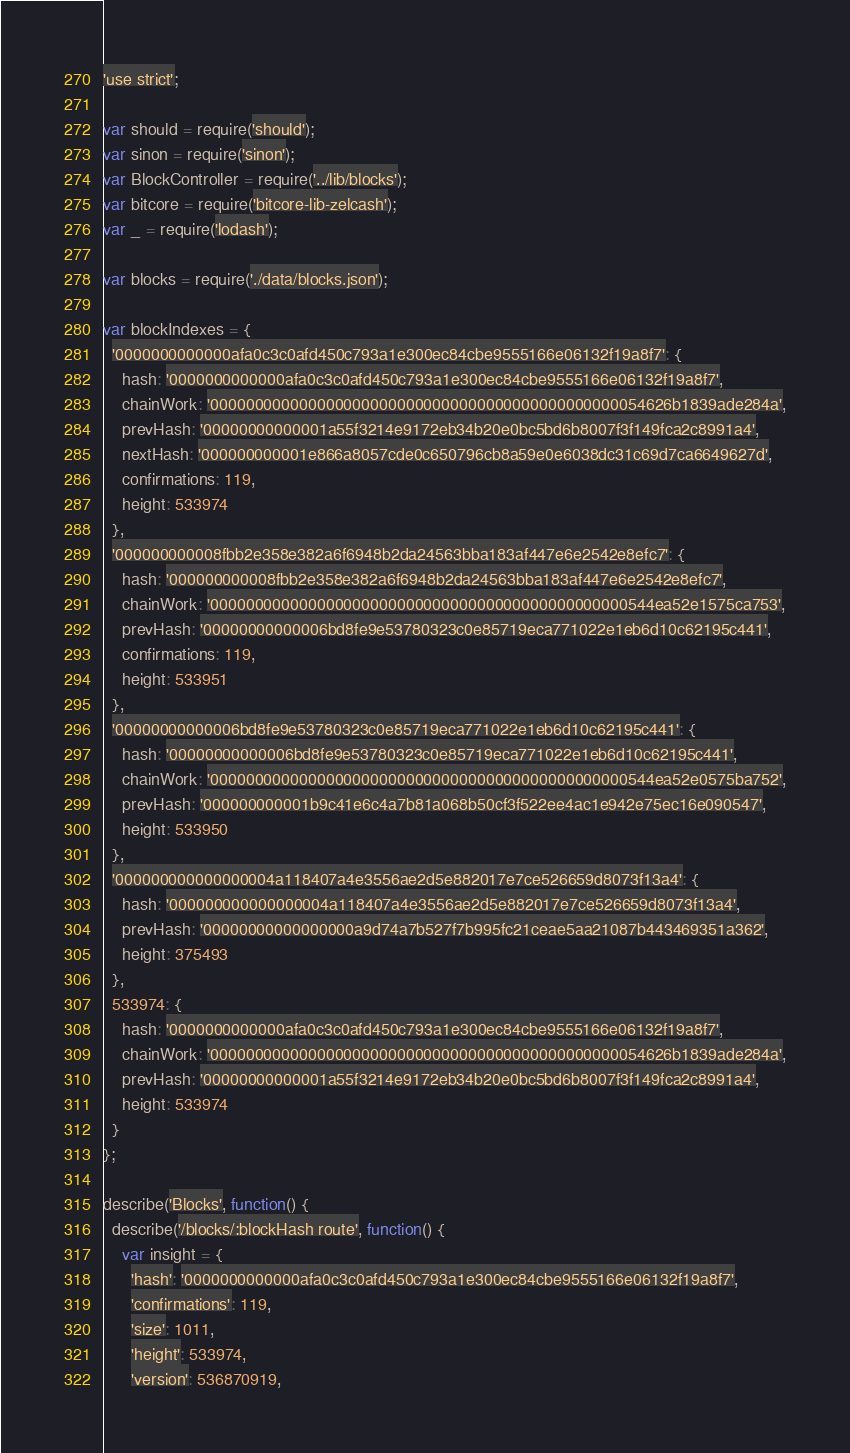<code> <loc_0><loc_0><loc_500><loc_500><_JavaScript_>'use strict';

var should = require('should');
var sinon = require('sinon');
var BlockController = require('../lib/blocks');
var bitcore = require('bitcore-lib-zelcash');
var _ = require('lodash');

var blocks = require('./data/blocks.json');

var blockIndexes = {
  '0000000000000afa0c3c0afd450c793a1e300ec84cbe9555166e06132f19a8f7': {
    hash: '0000000000000afa0c3c0afd450c793a1e300ec84cbe9555166e06132f19a8f7',
    chainWork: '0000000000000000000000000000000000000000000000054626b1839ade284a',
    prevHash: '00000000000001a55f3214e9172eb34b20e0bc5bd6b8007f3f149fca2c8991a4',
    nextHash: '000000000001e866a8057cde0c650796cb8a59e0e6038dc31c69d7ca6649627d',
    confirmations: 119,
    height: 533974
  },
  '000000000008fbb2e358e382a6f6948b2da24563bba183af447e6e2542e8efc7': {
    hash: '000000000008fbb2e358e382a6f6948b2da24563bba183af447e6e2542e8efc7',
    chainWork: '00000000000000000000000000000000000000000000000544ea52e1575ca753',
    prevHash: '00000000000006bd8fe9e53780323c0e85719eca771022e1eb6d10c62195c441',
    confirmations: 119,
    height: 533951
  },
  '00000000000006bd8fe9e53780323c0e85719eca771022e1eb6d10c62195c441': {
    hash: '00000000000006bd8fe9e53780323c0e85719eca771022e1eb6d10c62195c441',
    chainWork: '00000000000000000000000000000000000000000000000544ea52e0575ba752',
    prevHash: '000000000001b9c41e6c4a7b81a068b50cf3f522ee4ac1e942e75ec16e090547',
    height: 533950
  },
  '000000000000000004a118407a4e3556ae2d5e882017e7ce526659d8073f13a4': {
    hash: '000000000000000004a118407a4e3556ae2d5e882017e7ce526659d8073f13a4',
    prevHash: '00000000000000000a9d74a7b527f7b995fc21ceae5aa21087b443469351a362',
    height: 375493
  },
  533974: {
    hash: '0000000000000afa0c3c0afd450c793a1e300ec84cbe9555166e06132f19a8f7',
    chainWork: '0000000000000000000000000000000000000000000000054626b1839ade284a',
    prevHash: '00000000000001a55f3214e9172eb34b20e0bc5bd6b8007f3f149fca2c8991a4',
    height: 533974
  }
};

describe('Blocks', function() {
  describe('/blocks/:blockHash route', function() {
    var insight = {
      'hash': '0000000000000afa0c3c0afd450c793a1e300ec84cbe9555166e06132f19a8f7',
      'confirmations': 119,
      'size': 1011,
      'height': 533974,
      'version': 536870919,</code> 